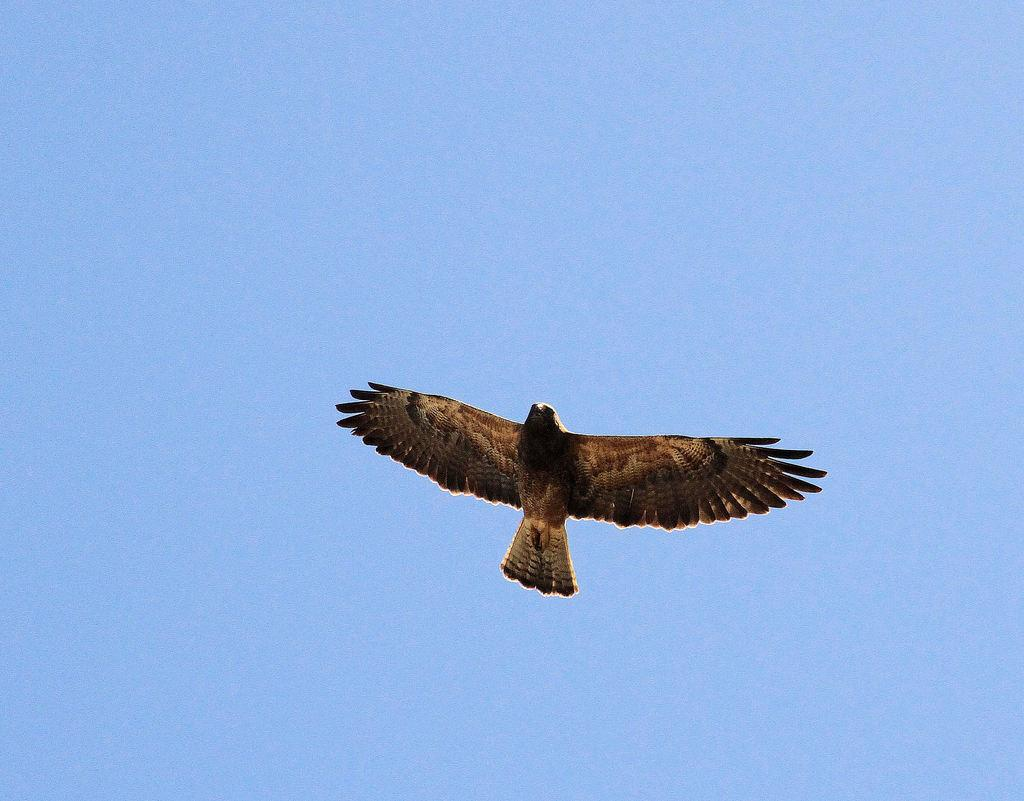What type of animal can be seen in the image? There is a bird in the image. Where is the bird located in the image? The bird is in the air. What colors can be observed on the bird? The bird has brown and cream colors. What is the color of the sky in the background of the image? The sky in the background is blue. What type of locket is the bird wearing around its throat in the image? There is no locket present around the bird's throat in the image. How many rats can be seen interacting with the bird in the image? There are no rats present in the image; it only features a bird. 